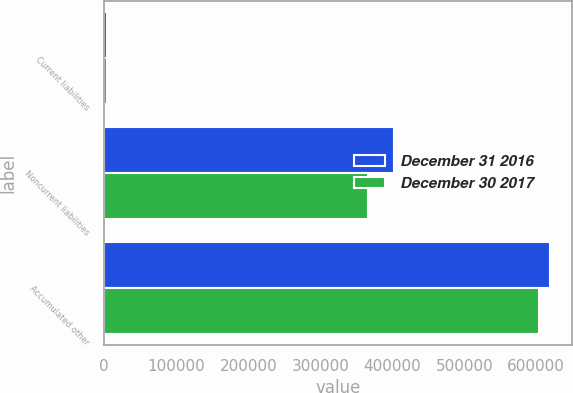Convert chart to OTSL. <chart><loc_0><loc_0><loc_500><loc_500><stacked_bar_chart><ecel><fcel>Current liabilities<fcel>Noncurrent liabilities<fcel>Accumulated other<nl><fcel>December 31 2016<fcel>3663<fcel>401749<fcel>618416<nl><fcel>December 30 2017<fcel>3605<fcel>366822<fcel>603610<nl></chart> 